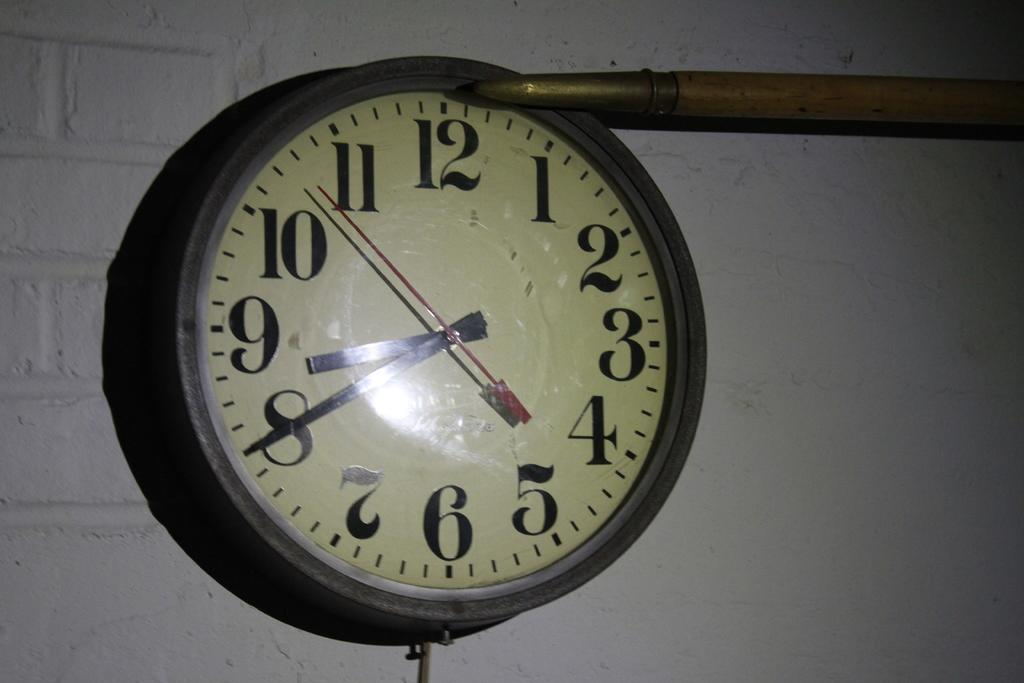<image>
Write a terse but informative summary of the picture. A large clock has hands displaying a time of eight forty. 